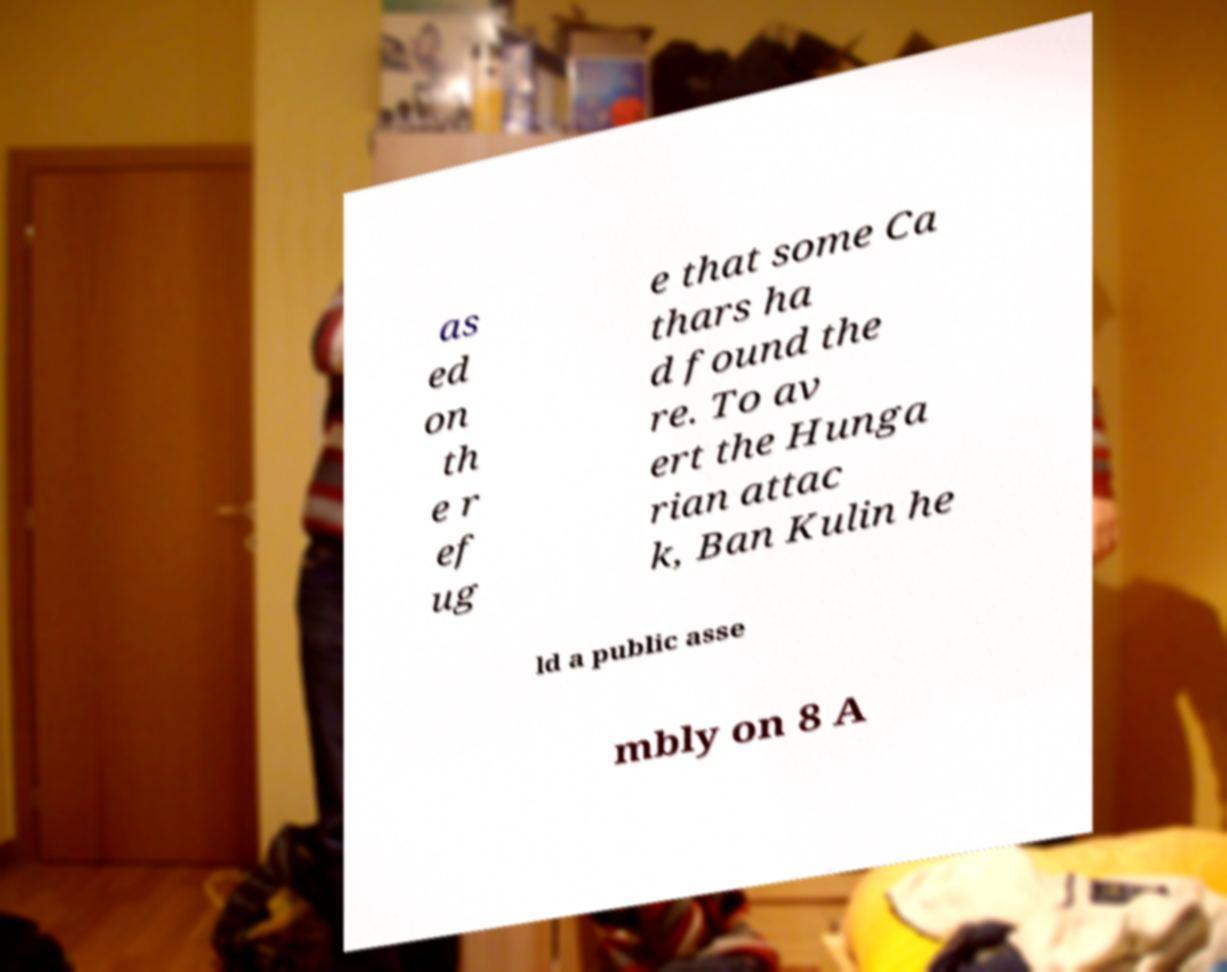Could you extract and type out the text from this image? as ed on th e r ef ug e that some Ca thars ha d found the re. To av ert the Hunga rian attac k, Ban Kulin he ld a public asse mbly on 8 A 